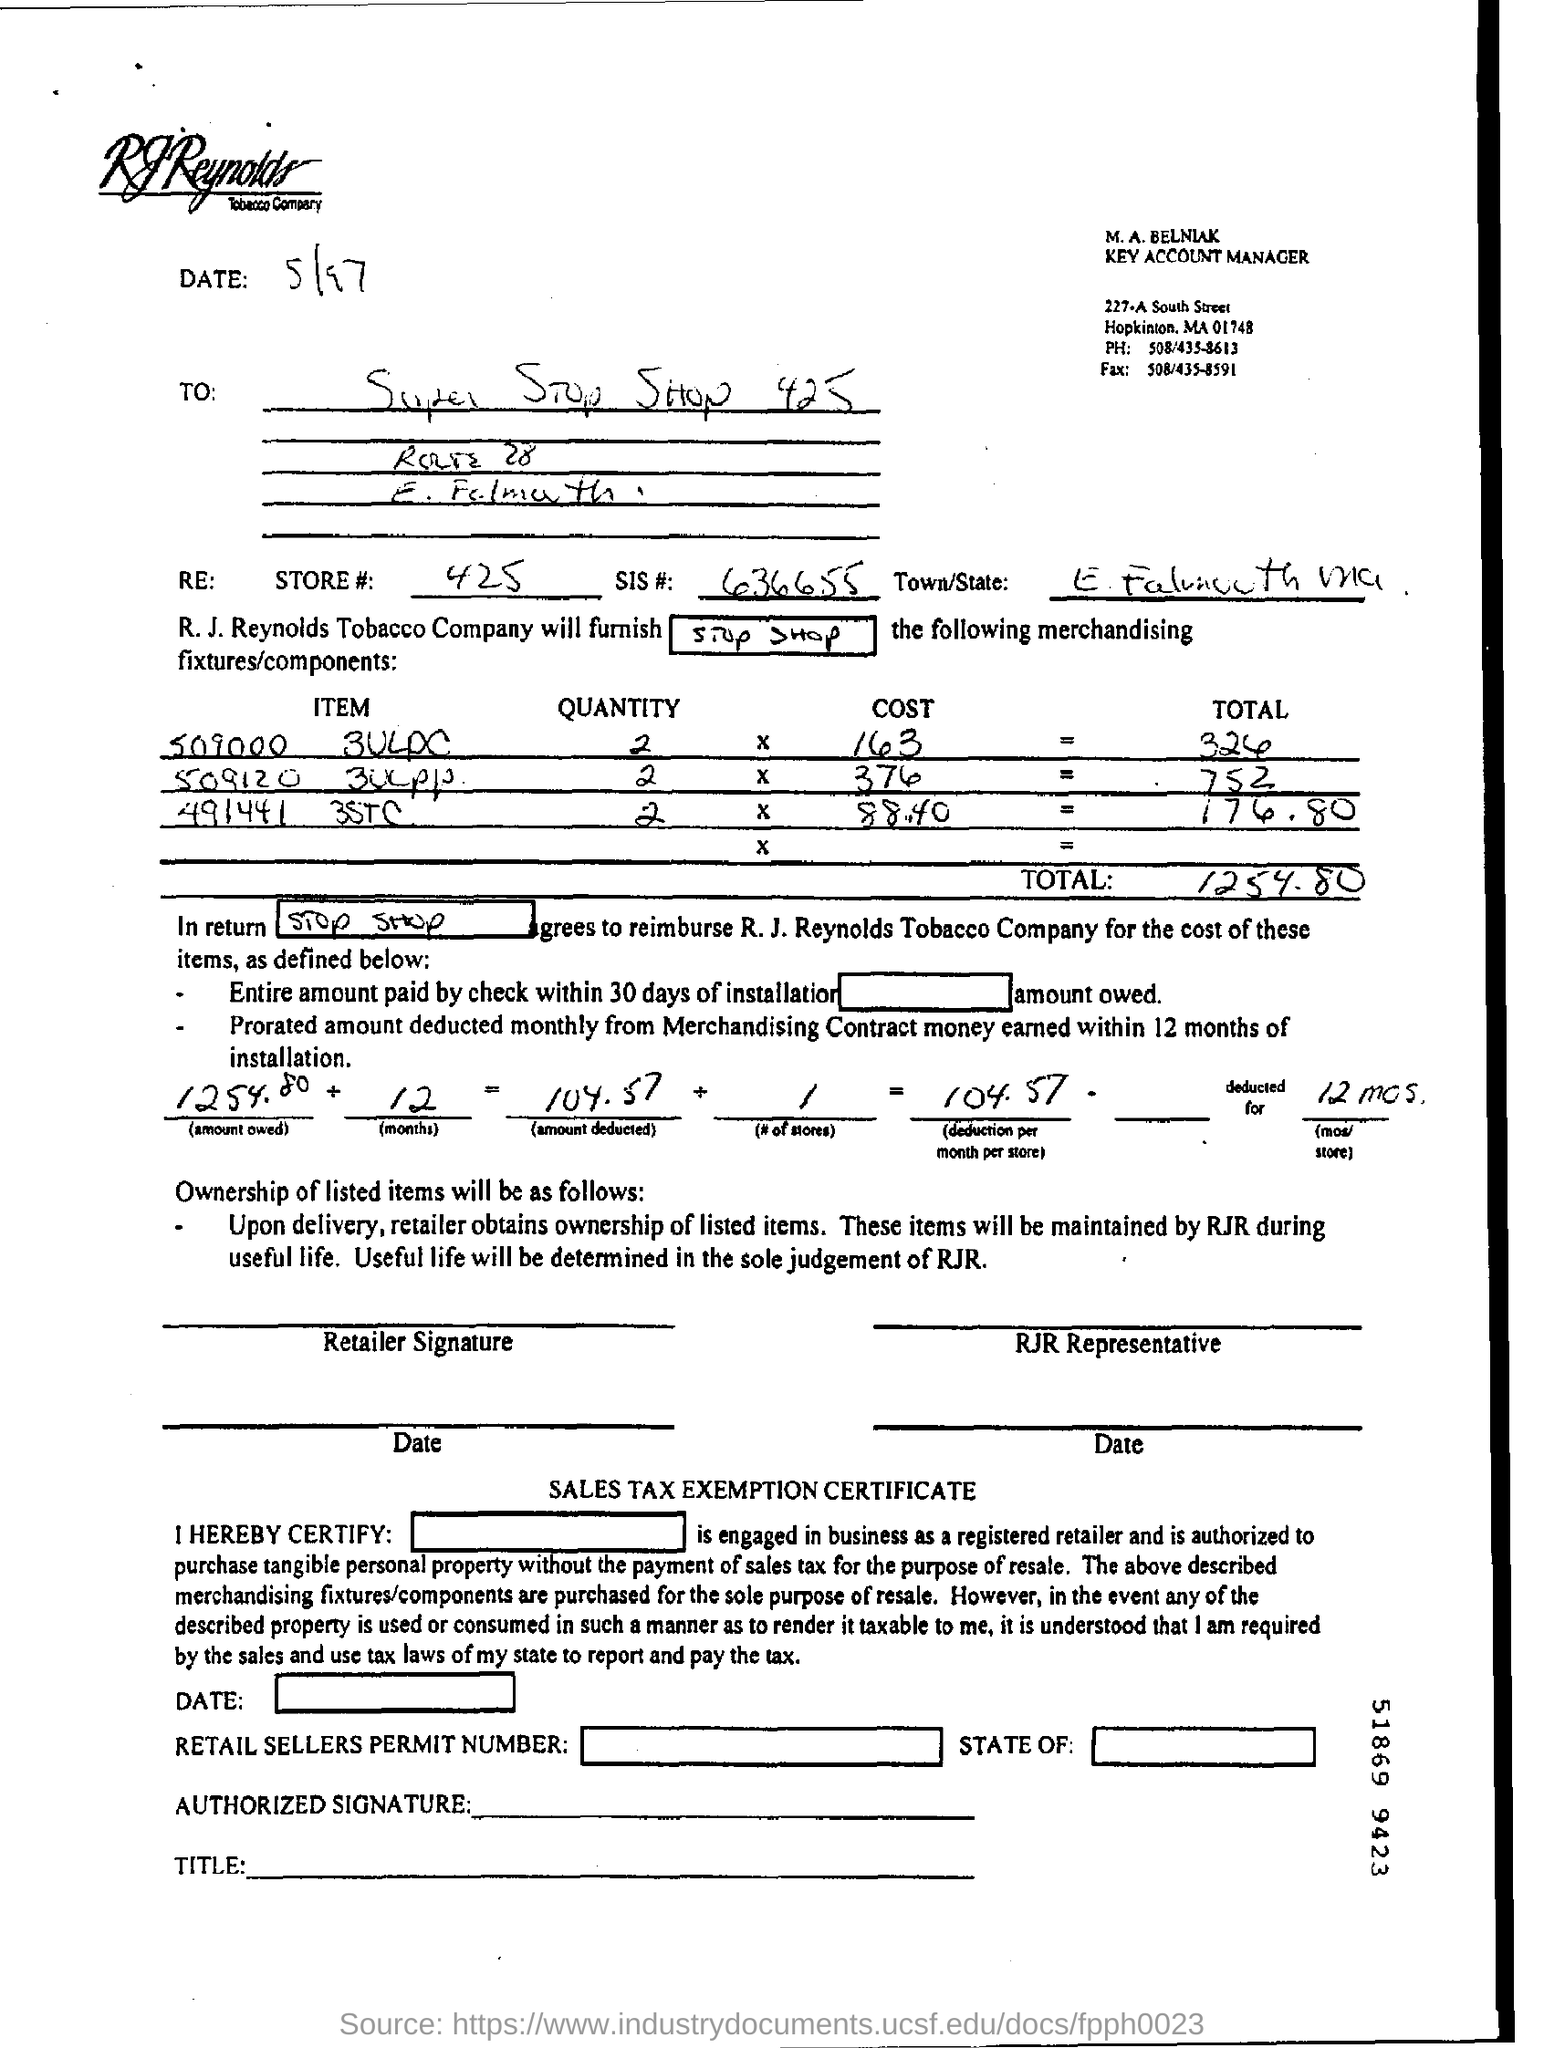Mention a couple of crucial points in this snapshot. Your total cost is $1,254.80. SIS #636655 is a unique identifier. The date mentioned in this document is 5/97. 